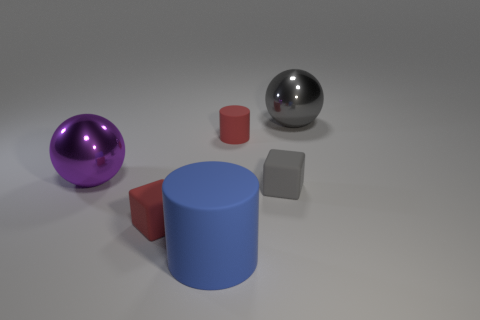There is a big shiny thing that is on the right side of the large purple ball; is its color the same as the matte object behind the gray matte block?
Give a very brief answer. No. Are there fewer tiny red cylinders in front of the big matte cylinder than metal spheres that are on the left side of the purple shiny object?
Your response must be concise. No. Is there any other thing that has the same shape as the large purple thing?
Provide a short and direct response. Yes. What color is the other thing that is the same shape as the large blue matte object?
Give a very brief answer. Red. Is the shape of the gray metal object the same as the red thing to the left of the blue matte thing?
Ensure brevity in your answer.  No. What number of things are either matte things left of the tiny gray rubber thing or matte things that are in front of the tiny red rubber cylinder?
Offer a terse response. 4. What is the big blue cylinder made of?
Your answer should be very brief. Rubber. How many other objects are there of the same size as the blue thing?
Make the answer very short. 2. There is a metallic thing to the right of the red cylinder; how big is it?
Ensure brevity in your answer.  Large. What material is the big ball that is to the right of the large metallic ball that is left of the shiny thing on the right side of the blue cylinder made of?
Offer a very short reply. Metal. 